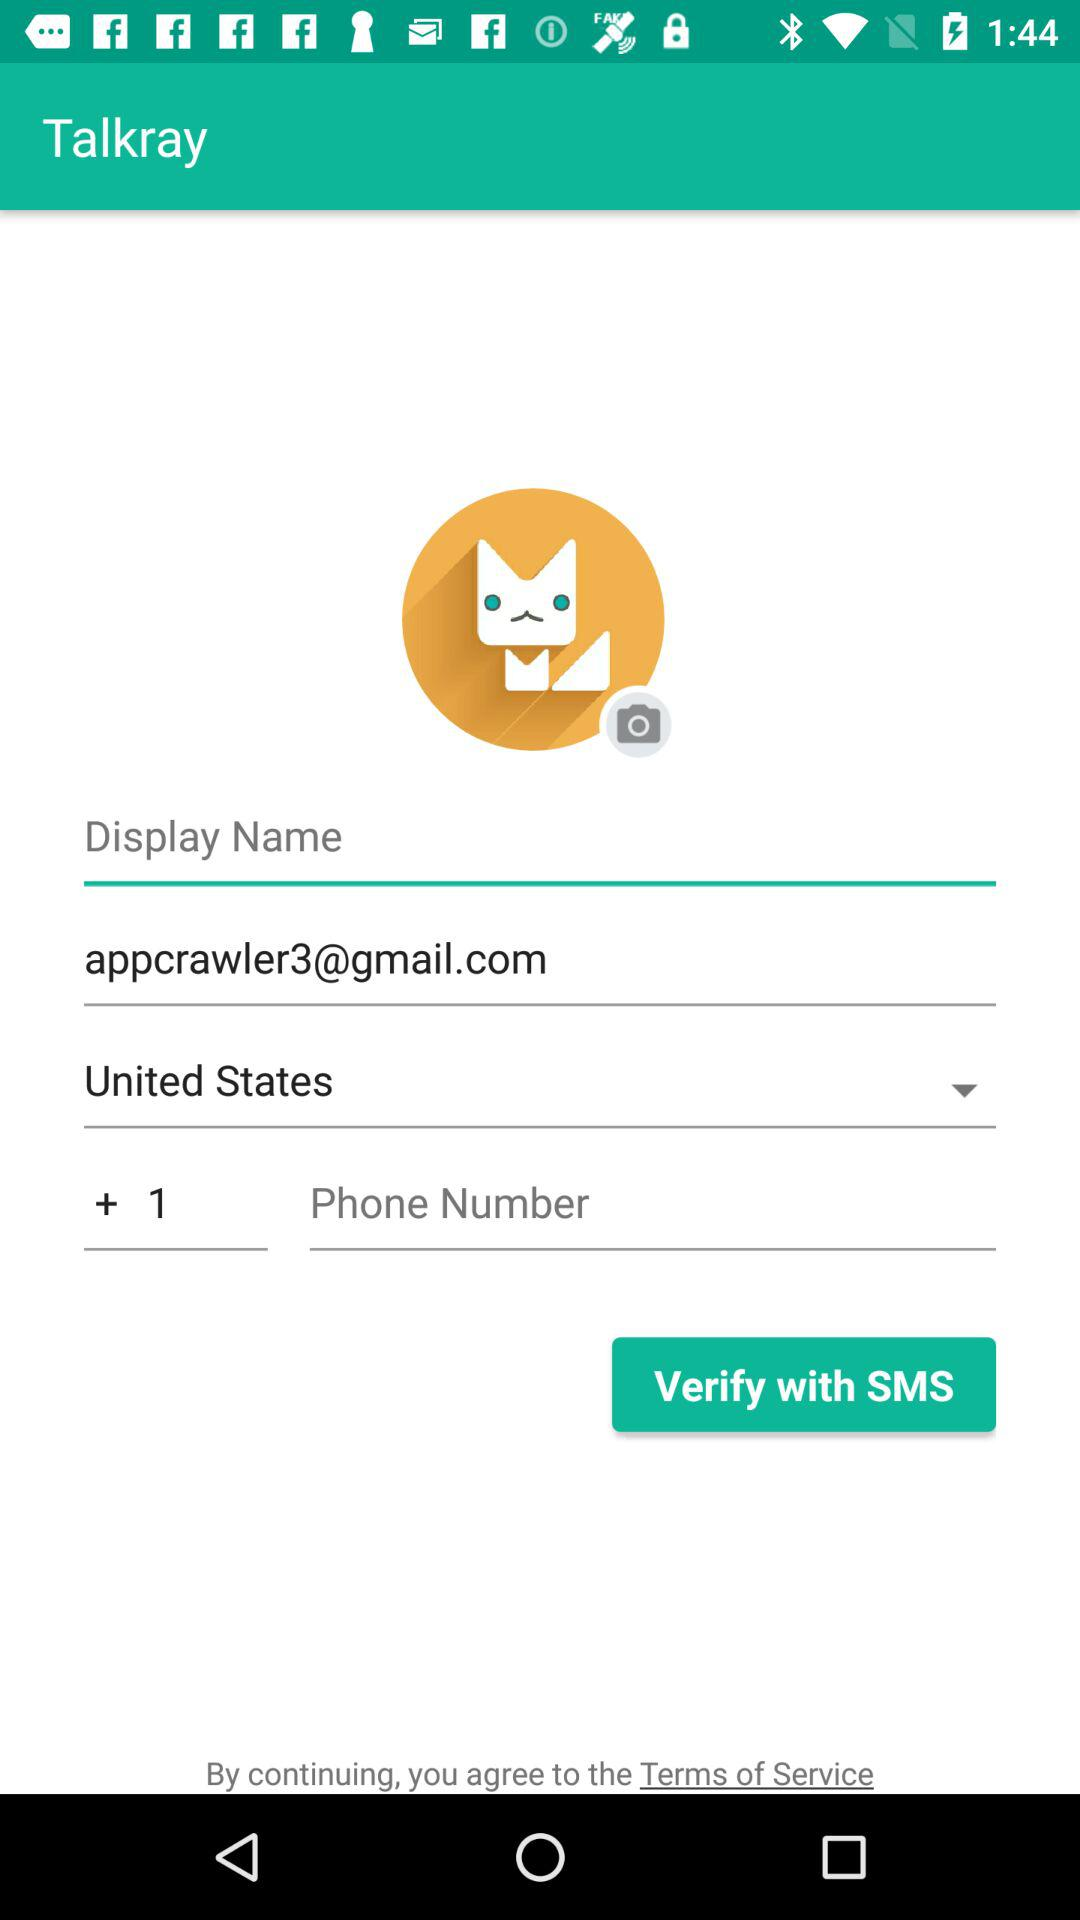What is the application name? The application name is "Talkray". 